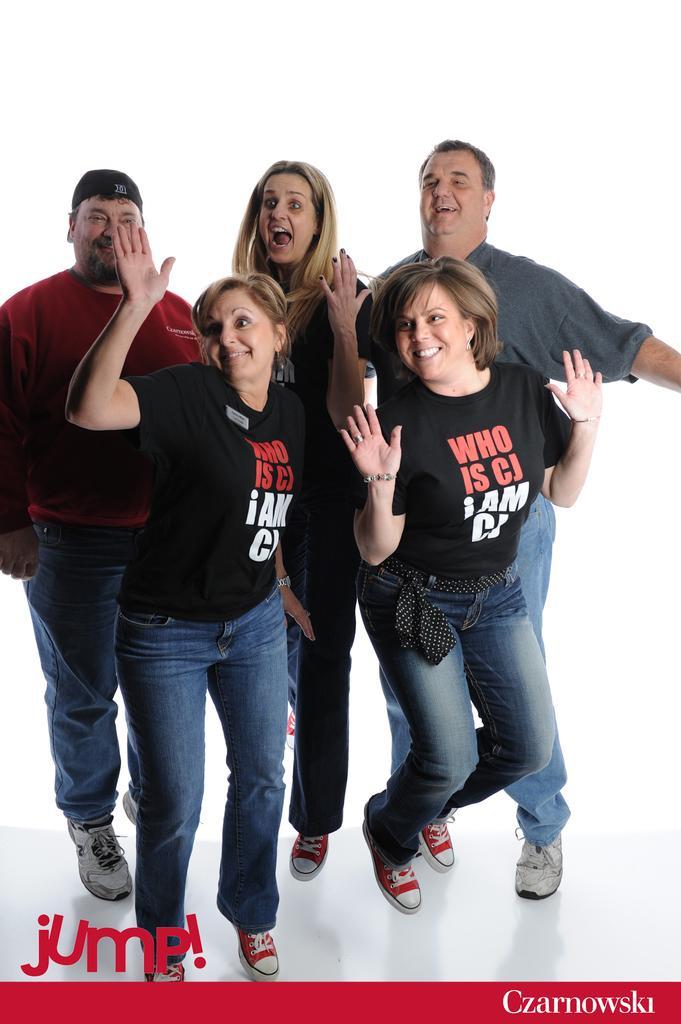Could you give a brief overview of what you see in this image? In the image few people are standing and smiling. 